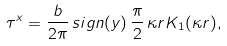<formula> <loc_0><loc_0><loc_500><loc_500>\tau ^ { x } = \frac { b } { 2 \pi } \, { s i g n } ( y ) \, \frac { \pi } { 2 } \, \kappa r K _ { 1 } ( \kappa r ) ,</formula> 